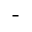Convert formula to latex. <formula><loc_0><loc_0><loc_500><loc_500>-</formula> 